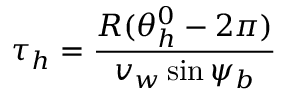Convert formula to latex. <formula><loc_0><loc_0><loc_500><loc_500>\tau _ { h } = \frac { R ( \theta _ { h } ^ { 0 } - 2 \pi ) } { v _ { w } \sin \psi _ { b } }</formula> 